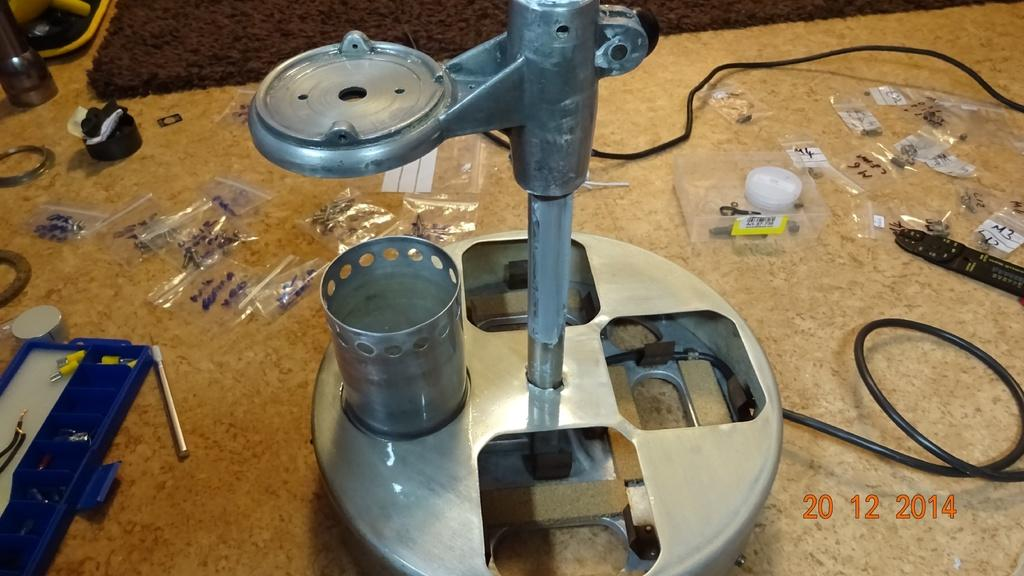What is the main subject in the image? There is a machine in the image. Can you describe the machine's components in the image? The machine's parts are visible in the image. Where is the machine and its parts located in the image? The machine and its parts are on the floor in the image. What type of brain can be seen inside the machine in the image? There is no brain visible inside the machine in the image. What does the machine smell like in the image? The image does not provide any information about the smell of the machine. Are there any sheep present in the image? There are no sheep present in the image. 